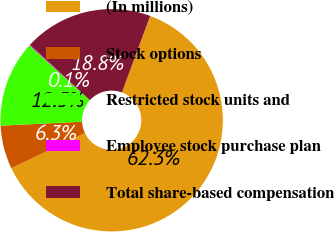Convert chart to OTSL. <chart><loc_0><loc_0><loc_500><loc_500><pie_chart><fcel>(In millions)<fcel>Stock options<fcel>Restricted stock units and<fcel>Employee stock purchase plan<fcel>Total share-based compensation<nl><fcel>62.27%<fcel>6.32%<fcel>12.54%<fcel>0.11%<fcel>18.76%<nl></chart> 